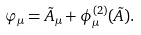<formula> <loc_0><loc_0><loc_500><loc_500>\varphi _ { \mu } = \tilde { A } _ { \mu } + \phi _ { \mu } ^ { ( 2 ) } ( \tilde { A } ) .</formula> 